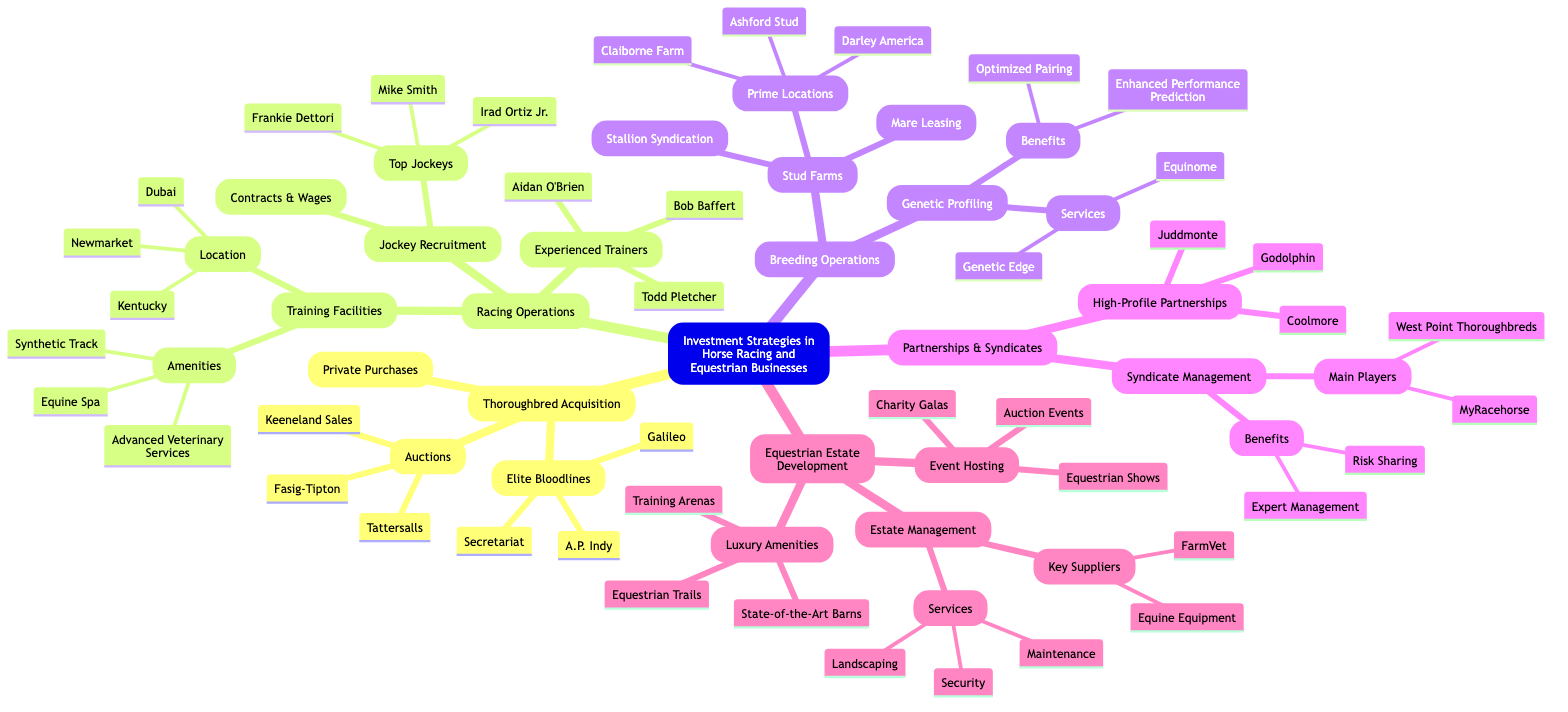What are the three elite bloodlines listed under Thoroughbred Acquisition? The node labeled "Elite Bloodlines" under "Thoroughbred Acquisition" provides three distinct bloodlines: A.P. Indy, Galileo, and Secretariat.
Answer: A.P. Indy, Galileo, Secretariat How many experienced trainers are mentioned? The "Experienced Trainers" node contains three specific names: Bob Baffert, Aidan O'Brien, and Todd Pletcher. Therefore, the count is three trainers.
Answer: 3 Which training facility amenities are listed? The "Amenities" node under "Training Facilities" includes three items: Equine Spa, Synthetic Track, and Advanced Veterinary Services.
Answer: Equine Spa, Synthetic Track, Advanced Veterinary Services What are the benefits of genetic profiling? The node "Benefits" within "Genetic Profiling" highlights two advantages: Optimized Pairing and Enhanced Performance Prediction, providing insight into the positive outcomes of genetic profiling.
Answer: Optimized Pairing, Enhanced Performance Prediction How many prime locations are noted under Stud Farms? Within the "Stud Farms" section, specifically under "Prime Locations," three locations are indicated: Ashford Stud, Darley America, and Claiborne Farm. Thus, the number is three.
Answer: 3 Which luxury amenities are mentioned for Equestrian Estate Development? The node "Luxury Amenities" includes three specific items: State-of-the-Art Barns, Equestrian Trails, and Training Arenas, which are central to the concept of luxury in equestrian estate development.
Answer: State-of-the-Art Barns, Equestrian Trails, Training Arenas What is the purpose of syndicate management? The "Benefits" node under "Syndicate Management" identifies two key purposes: Risk Sharing and Expert Management, which underscore the advantages of proper syndicate oversight.
Answer: Risk Sharing, Expert Management Who are the main players listed in syndicate management? The node labeled "Main Players" under "Syndicate Management" presents two entities: MyRacehorse and West Point Thoroughbreds, indicating the key organizations involved in this domain.
Answer: MyRacehorse, West Point Thoroughbreds What are the types of events hosted in equestrian estate development? The "Event Hosting" node lists three types of events: Charity Galas, Auction Events, and Equestrian Shows, showcasing the variety of occasions that can be organized.
Answer: Charity Galas, Auction Events, Equestrian Shows 